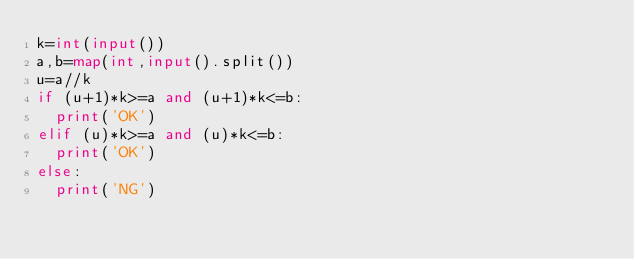<code> <loc_0><loc_0><loc_500><loc_500><_Python_>k=int(input())
a,b=map(int,input().split())
u=a//k
if (u+1)*k>=a and (u+1)*k<=b:
	print('OK')
elif (u)*k>=a and (u)*k<=b:
	print('OK')
else:
	print('NG')</code> 